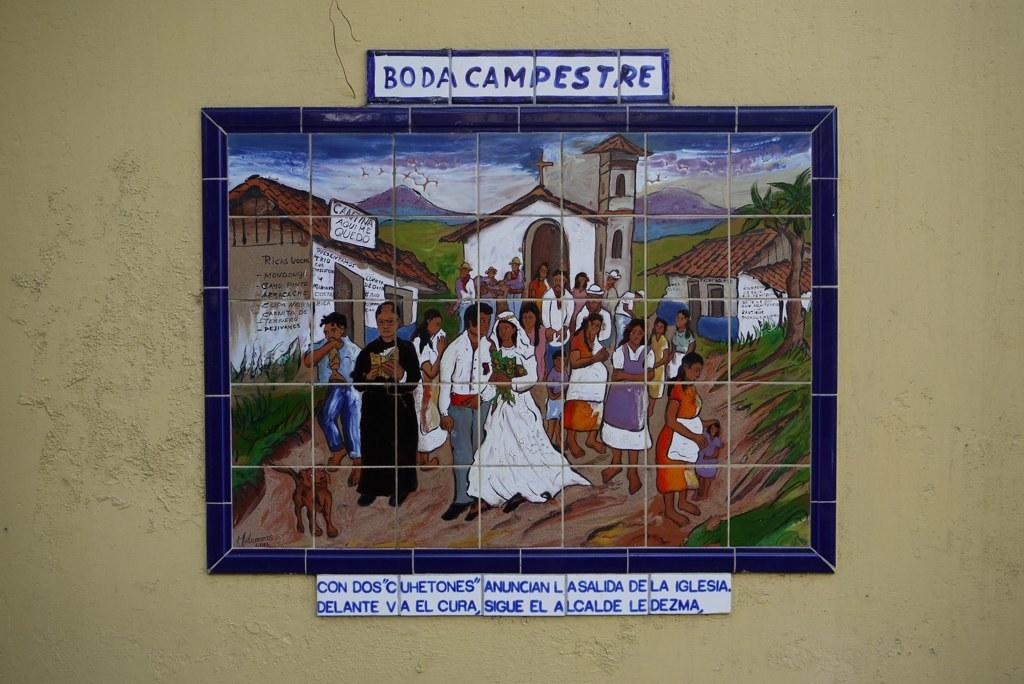What does it say just above the artwork?
Make the answer very short. Boda campestre. 